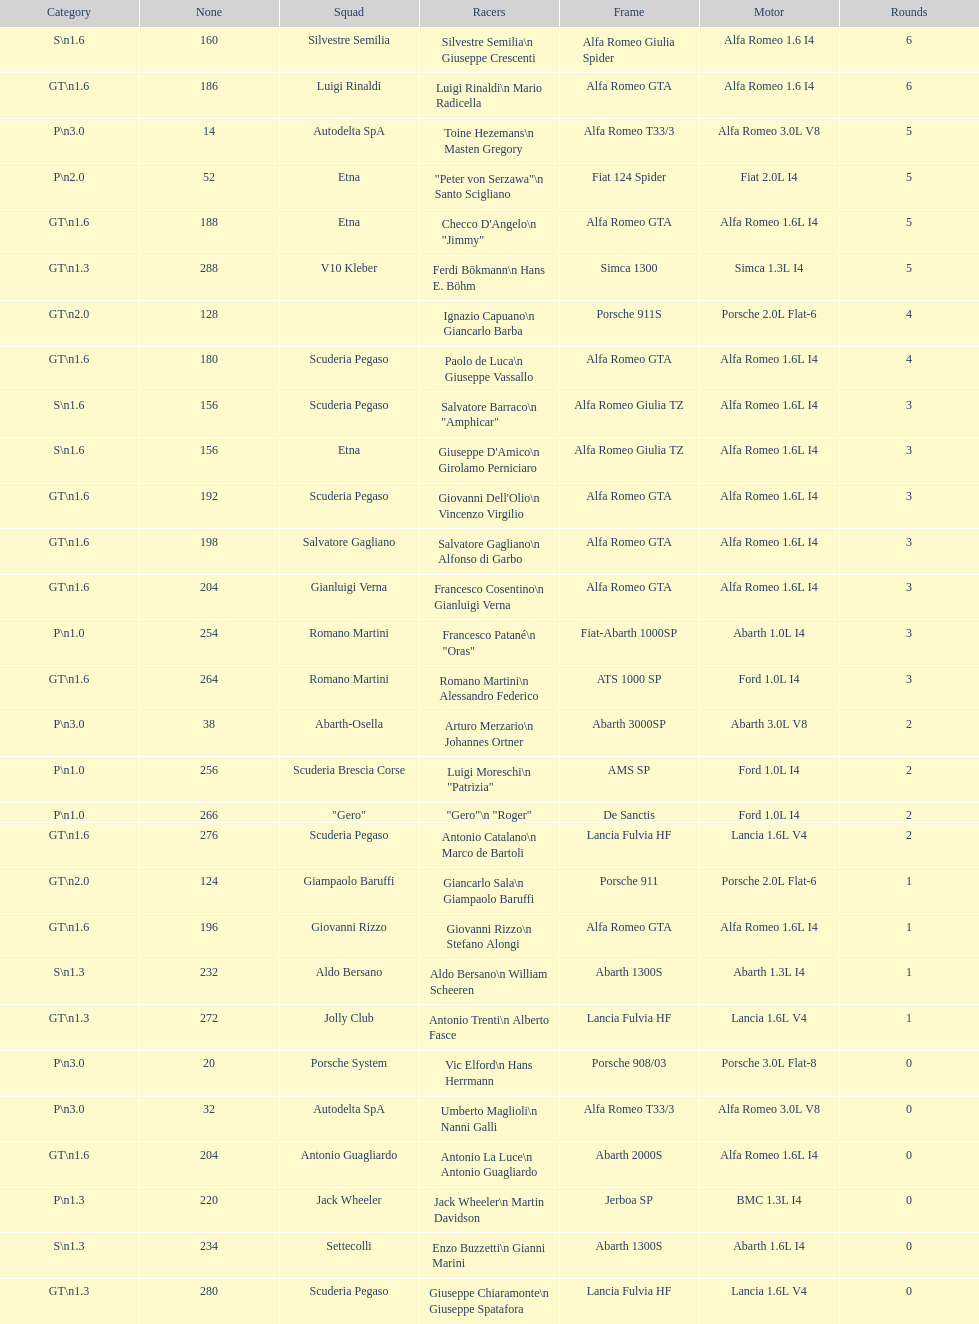Would you mind parsing the complete table? {'header': ['Category', 'None', 'Squad', 'Racers', 'Frame', 'Motor', 'Rounds'], 'rows': [['S\\n1.6', '160', 'Silvestre Semilia', 'Silvestre Semilia\\n Giuseppe Crescenti', 'Alfa Romeo Giulia Spider', 'Alfa Romeo 1.6 I4', '6'], ['GT\\n1.6', '186', 'Luigi Rinaldi', 'Luigi Rinaldi\\n Mario Radicella', 'Alfa Romeo GTA', 'Alfa Romeo 1.6 I4', '6'], ['P\\n3.0', '14', 'Autodelta SpA', 'Toine Hezemans\\n Masten Gregory', 'Alfa Romeo T33/3', 'Alfa Romeo 3.0L V8', '5'], ['P\\n2.0', '52', 'Etna', '"Peter von Serzawa"\\n Santo Scigliano', 'Fiat 124 Spider', 'Fiat 2.0L I4', '5'], ['GT\\n1.6', '188', 'Etna', 'Checco D\'Angelo\\n "Jimmy"', 'Alfa Romeo GTA', 'Alfa Romeo 1.6L I4', '5'], ['GT\\n1.3', '288', 'V10 Kleber', 'Ferdi Bökmann\\n Hans E. Böhm', 'Simca 1300', 'Simca 1.3L I4', '5'], ['GT\\n2.0', '128', '', 'Ignazio Capuano\\n Giancarlo Barba', 'Porsche 911S', 'Porsche 2.0L Flat-6', '4'], ['GT\\n1.6', '180', 'Scuderia Pegaso', 'Paolo de Luca\\n Giuseppe Vassallo', 'Alfa Romeo GTA', 'Alfa Romeo 1.6L I4', '4'], ['S\\n1.6', '156', 'Scuderia Pegaso', 'Salvatore Barraco\\n "Amphicar"', 'Alfa Romeo Giulia TZ', 'Alfa Romeo 1.6L I4', '3'], ['S\\n1.6', '156', 'Etna', "Giuseppe D'Amico\\n Girolamo Perniciaro", 'Alfa Romeo Giulia TZ', 'Alfa Romeo 1.6L I4', '3'], ['GT\\n1.6', '192', 'Scuderia Pegaso', "Giovanni Dell'Olio\\n Vincenzo Virgilio", 'Alfa Romeo GTA', 'Alfa Romeo 1.6L I4', '3'], ['GT\\n1.6', '198', 'Salvatore Gagliano', 'Salvatore Gagliano\\n Alfonso di Garbo', 'Alfa Romeo GTA', 'Alfa Romeo 1.6L I4', '3'], ['GT\\n1.6', '204', 'Gianluigi Verna', 'Francesco Cosentino\\n Gianluigi Verna', 'Alfa Romeo GTA', 'Alfa Romeo 1.6L I4', '3'], ['P\\n1.0', '254', 'Romano Martini', 'Francesco Patané\\n "Oras"', 'Fiat-Abarth 1000SP', 'Abarth 1.0L I4', '3'], ['GT\\n1.6', '264', 'Romano Martini', 'Romano Martini\\n Alessandro Federico', 'ATS 1000 SP', 'Ford 1.0L I4', '3'], ['P\\n3.0', '38', 'Abarth-Osella', 'Arturo Merzario\\n Johannes Ortner', 'Abarth 3000SP', 'Abarth 3.0L V8', '2'], ['P\\n1.0', '256', 'Scuderia Brescia Corse', 'Luigi Moreschi\\n "Patrizia"', 'AMS SP', 'Ford 1.0L I4', '2'], ['P\\n1.0', '266', '"Gero"', '"Gero"\\n "Roger"', 'De Sanctis', 'Ford 1.0L I4', '2'], ['GT\\n1.6', '276', 'Scuderia Pegaso', 'Antonio Catalano\\n Marco de Bartoli', 'Lancia Fulvia HF', 'Lancia 1.6L V4', '2'], ['GT\\n2.0', '124', 'Giampaolo Baruffi', 'Giancarlo Sala\\n Giampaolo Baruffi', 'Porsche 911', 'Porsche 2.0L Flat-6', '1'], ['GT\\n1.6', '196', 'Giovanni Rizzo', 'Giovanni Rizzo\\n Stefano Alongi', 'Alfa Romeo GTA', 'Alfa Romeo 1.6L I4', '1'], ['S\\n1.3', '232', 'Aldo Bersano', 'Aldo Bersano\\n William Scheeren', 'Abarth 1300S', 'Abarth 1.3L I4', '1'], ['GT\\n1.3', '272', 'Jolly Club', 'Antonio Trenti\\n Alberto Fasce', 'Lancia Fulvia HF', 'Lancia 1.6L V4', '1'], ['P\\n3.0', '20', 'Porsche System', 'Vic Elford\\n Hans Herrmann', 'Porsche 908/03', 'Porsche 3.0L Flat-8', '0'], ['P\\n3.0', '32', 'Autodelta SpA', 'Umberto Maglioli\\n Nanni Galli', 'Alfa Romeo T33/3', 'Alfa Romeo 3.0L V8', '0'], ['GT\\n1.6', '204', 'Antonio Guagliardo', 'Antonio La Luce\\n Antonio Guagliardo', 'Abarth 2000S', 'Alfa Romeo 1.6L I4', '0'], ['P\\n1.3', '220', 'Jack Wheeler', 'Jack Wheeler\\n Martin Davidson', 'Jerboa SP', 'BMC 1.3L I4', '0'], ['S\\n1.3', '234', 'Settecolli', 'Enzo Buzzetti\\n Gianni Marini', 'Abarth 1300S', 'Abarth 1.6L I4', '0'], ['GT\\n1.3', '280', 'Scuderia Pegaso', 'Giuseppe Chiaramonte\\n Giuseppe Spatafora', 'Lancia Fulvia HF', 'Lancia 1.6L V4', '0']]} His nickname is "jimmy," but what is his full name? Checco D'Angelo. 